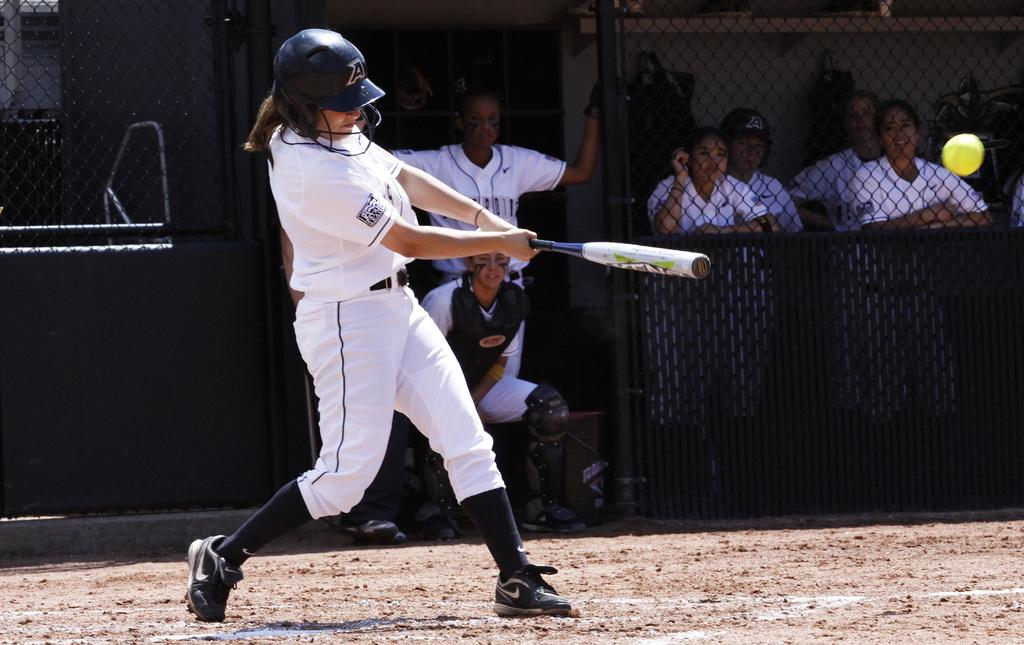<image>
Share a concise interpretation of the image provided. A batter with an A on their helmet takes a swing at the ball. 